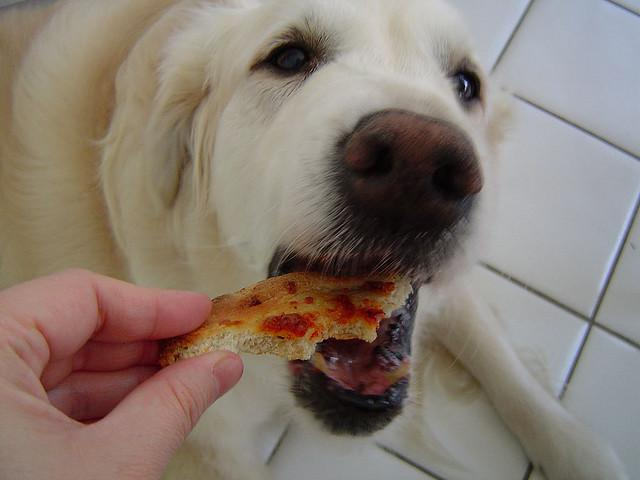What is the dog chowing down on?

Choices:
A) pizza
B) egg
C) baseball glove
D) shoes pizza 